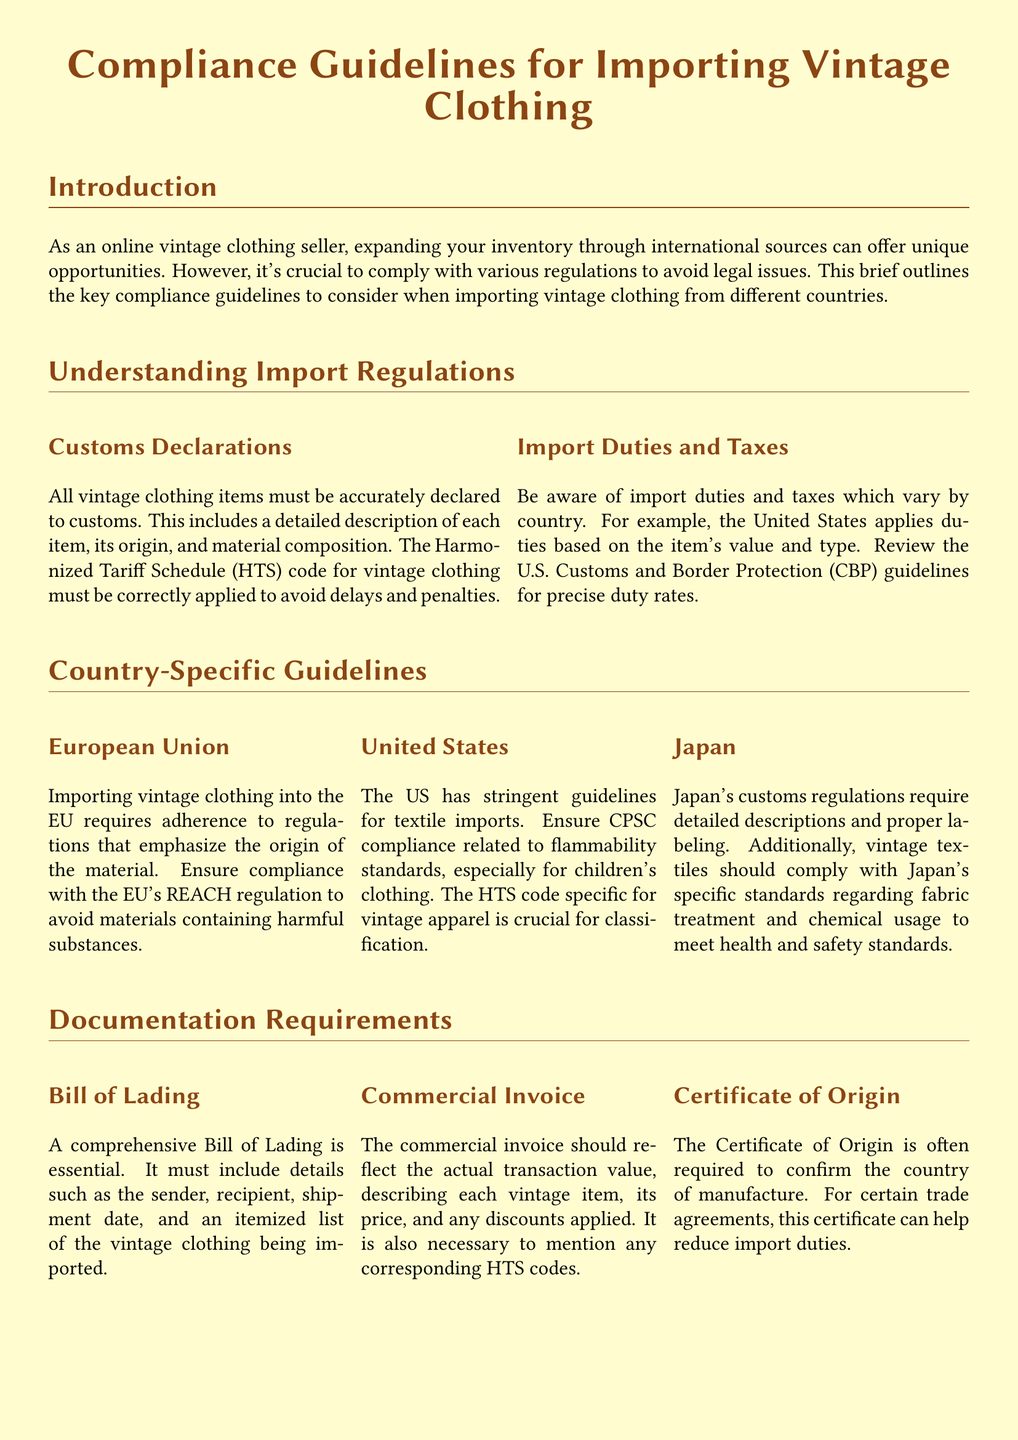What is the title of the document? The title is the main heading of the document that reflects its subject matter.
Answer: Compliance Guidelines for Importing Vintage Clothing What is one of the requirements for importing vintage clothing into the EU? The EU has specific regulations regarding materials to ensure safety and health standards, which require adherence.
Answer: REACH regulation What document must include shipment details for vintage clothing? This document is crucial for detailing the specifics of the shipment when importing goods.
Answer: Bill of Lading What must the commercial invoice reflect in terms of value? It should represent the actual transaction value of the items being imported.
Answer: Actual transaction value What should be ensured regarding children's clothing when importing into the US? This reflects a specific safety requirement imposed by US regulations on textile imports.
Answer: CPSC compliance Which country has specific fabric treatment standards? This country has unique rules governing the importation and labeling of textiles to ensure safety and health compliance.
Answer: Japan What type of practices should suppliers follow to enhance customer trust? This aspect emphasizes the importance of ethical sourcing in the vintage clothing market.
Answer: Fair trade practices What is a potential benefit of the Certificate of Origin? This document can be advantageous for reducing costs when importing under certain conditions.
Answer: Reduce import duties 